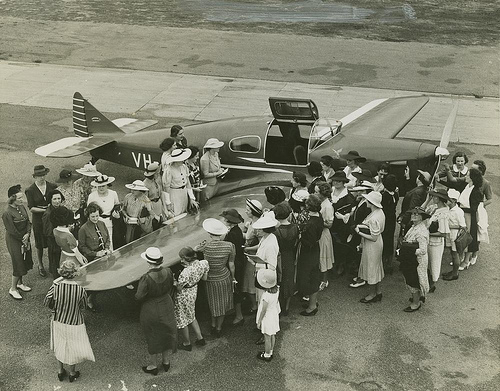What could be the significance of the airplane to the people? Given the era and the crowd's attention, the airplane might represent a novel technological marvel, a symbol of progress, or perhaps it's linked to a significant aviation event at the time. 